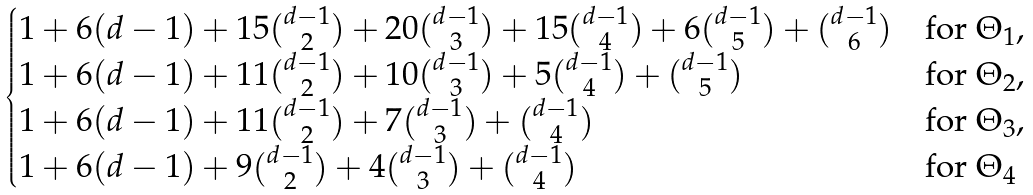<formula> <loc_0><loc_0><loc_500><loc_500>\begin{cases} 1 + 6 ( d - 1 ) + 1 5 \binom { d - 1 } { 2 } + 2 0 \binom { d - 1 } { 3 } + 1 5 \binom { d - 1 } { 4 } + 6 \binom { d - 1 } { 5 } + \binom { d - 1 } { 6 } & \text {for $\Theta_{1}$} , \\ 1 + 6 ( d - 1 ) + 1 1 \binom { d - 1 } { 2 } + 1 0 \binom { d - 1 } { 3 } + 5 \binom { d - 1 } { 4 } + \binom { d - 1 } { 5 } & \text {for $\Theta_{2}$} , \\ 1 + 6 ( d - 1 ) + 1 1 \binom { d - 1 } { 2 } + 7 \binom { d - 1 } { 3 } + \binom { d - 1 } { 4 } & \text {for $\Theta_{3}$} , \\ 1 + 6 ( d - 1 ) + 9 \binom { d - 1 } { 2 } + 4 \binom { d - 1 } { 3 } + \binom { d - 1 } { 4 } & \text {for $\Theta_{4}$} \end{cases}</formula> 